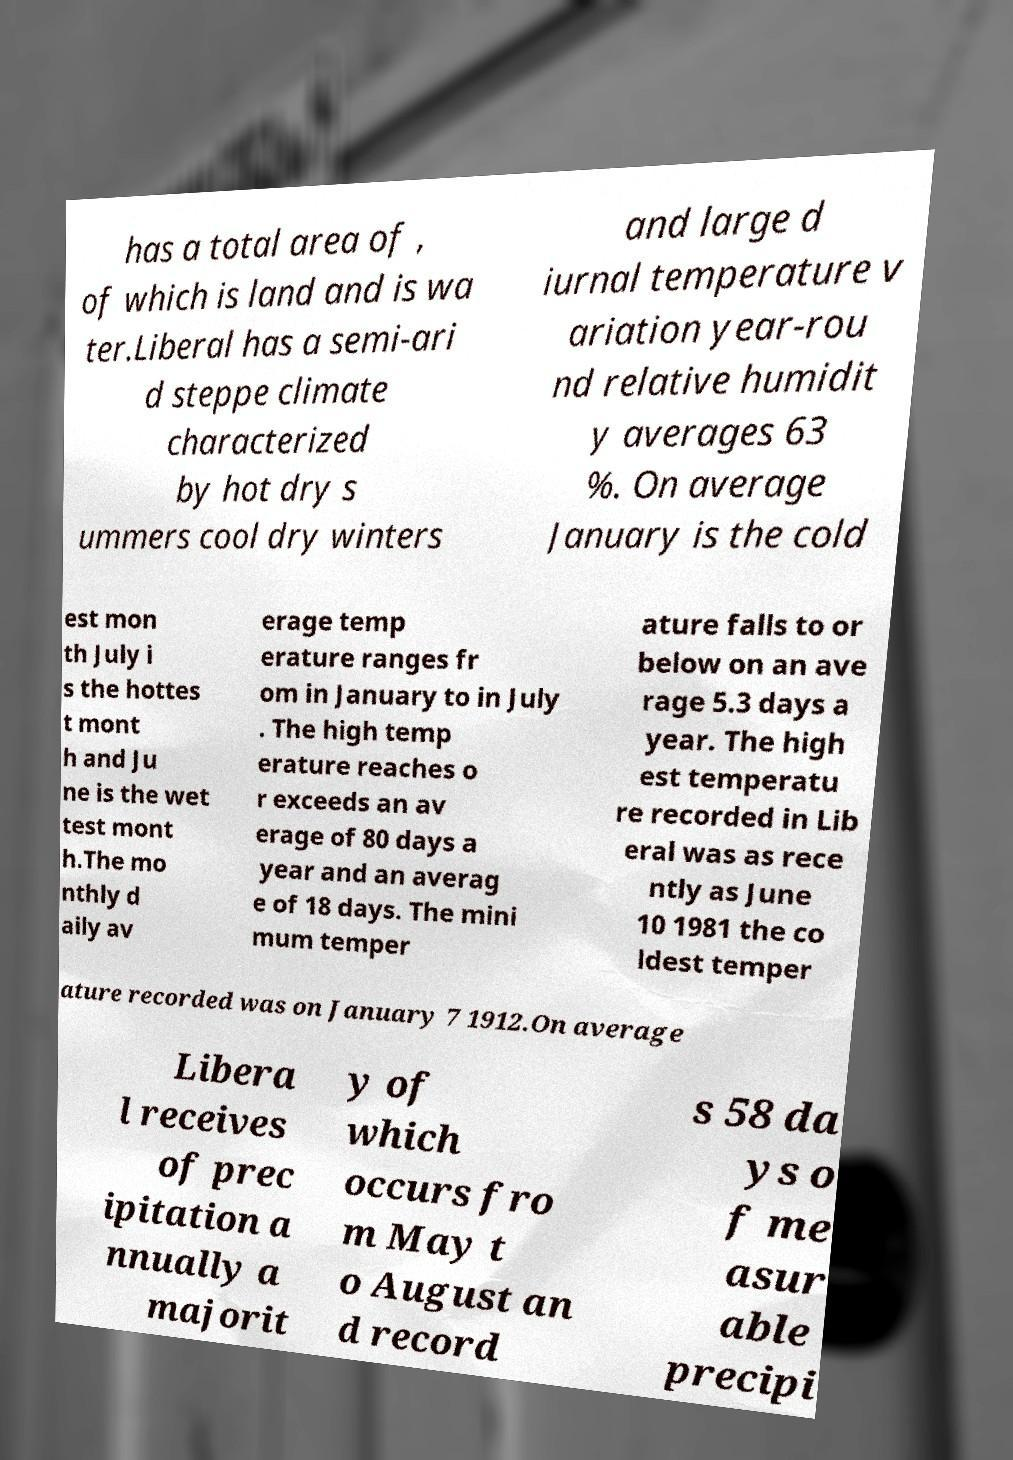Can you accurately transcribe the text from the provided image for me? has a total area of , of which is land and is wa ter.Liberal has a semi-ari d steppe climate characterized by hot dry s ummers cool dry winters and large d iurnal temperature v ariation year-rou nd relative humidit y averages 63 %. On average January is the cold est mon th July i s the hottes t mont h and Ju ne is the wet test mont h.The mo nthly d aily av erage temp erature ranges fr om in January to in July . The high temp erature reaches o r exceeds an av erage of 80 days a year and an averag e of 18 days. The mini mum temper ature falls to or below on an ave rage 5.3 days a year. The high est temperatu re recorded in Lib eral was as rece ntly as June 10 1981 the co ldest temper ature recorded was on January 7 1912.On average Libera l receives of prec ipitation a nnually a majorit y of which occurs fro m May t o August an d record s 58 da ys o f me asur able precipi 